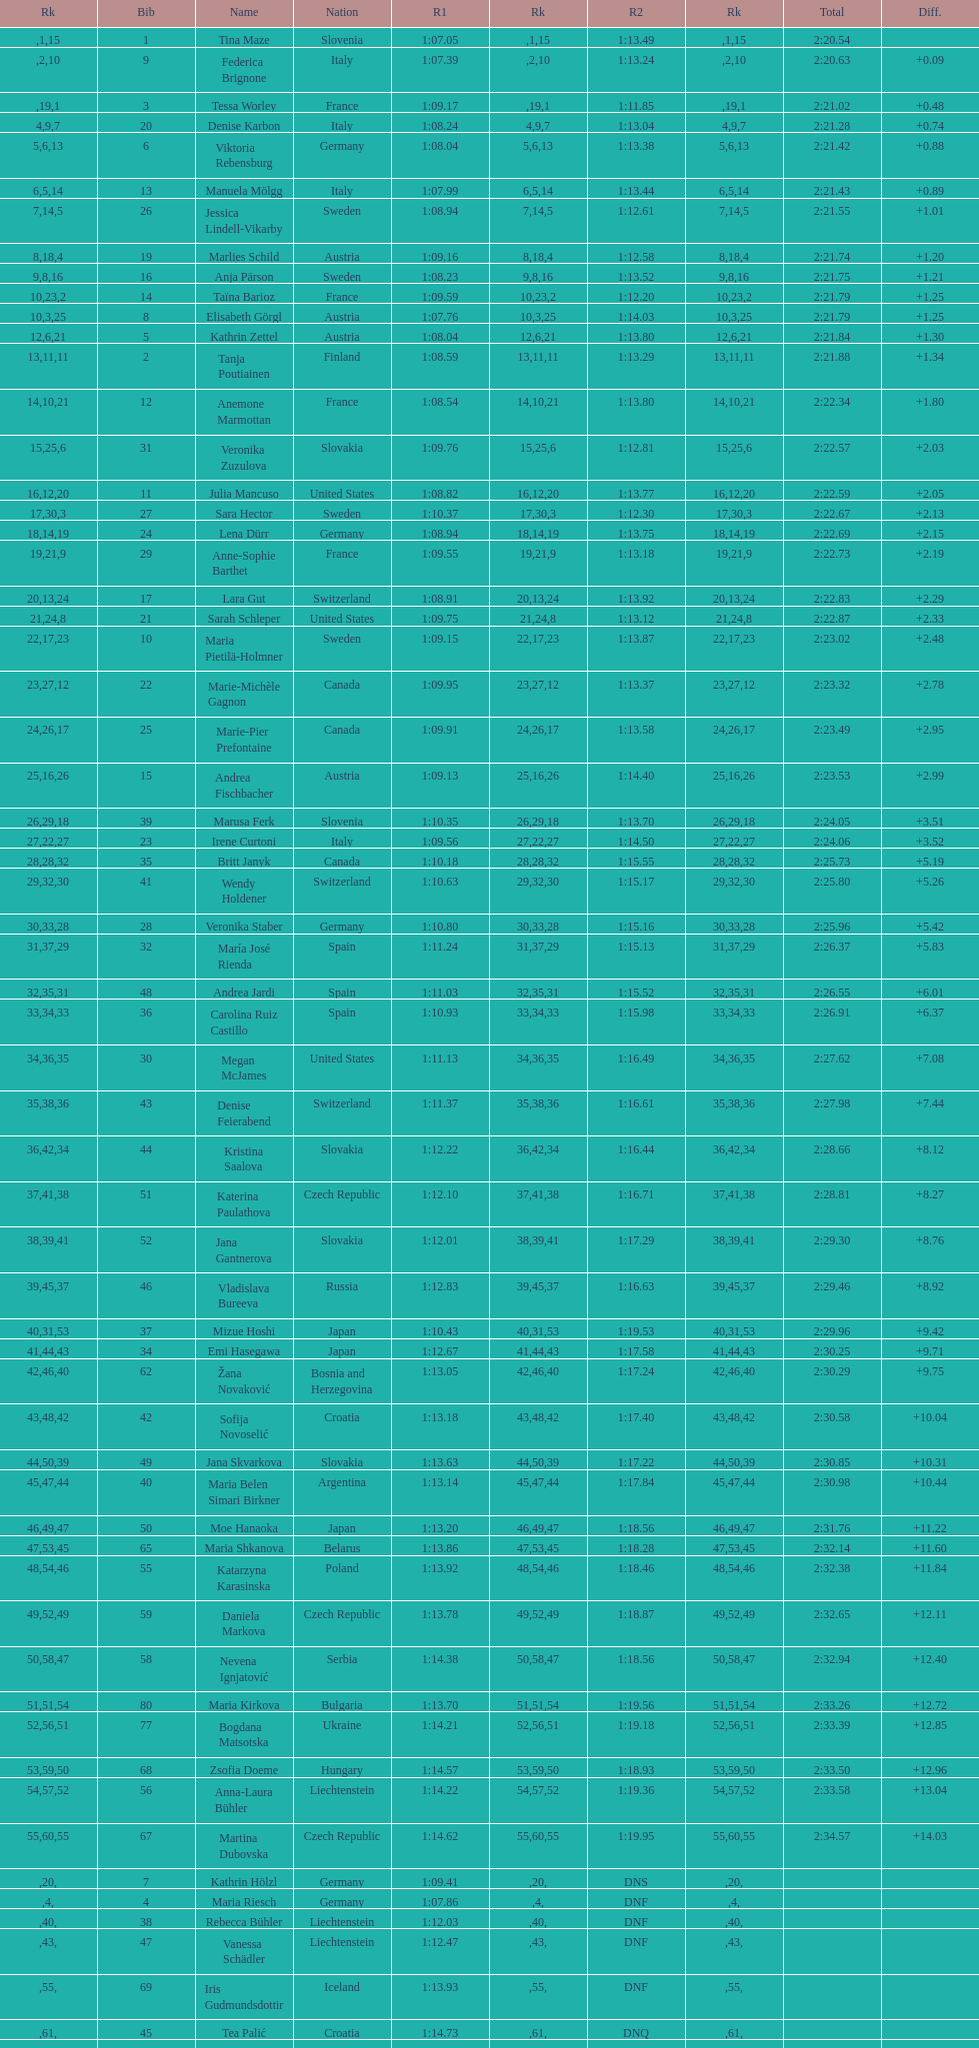Who ranked next after federica brignone? Tessa Worley. 